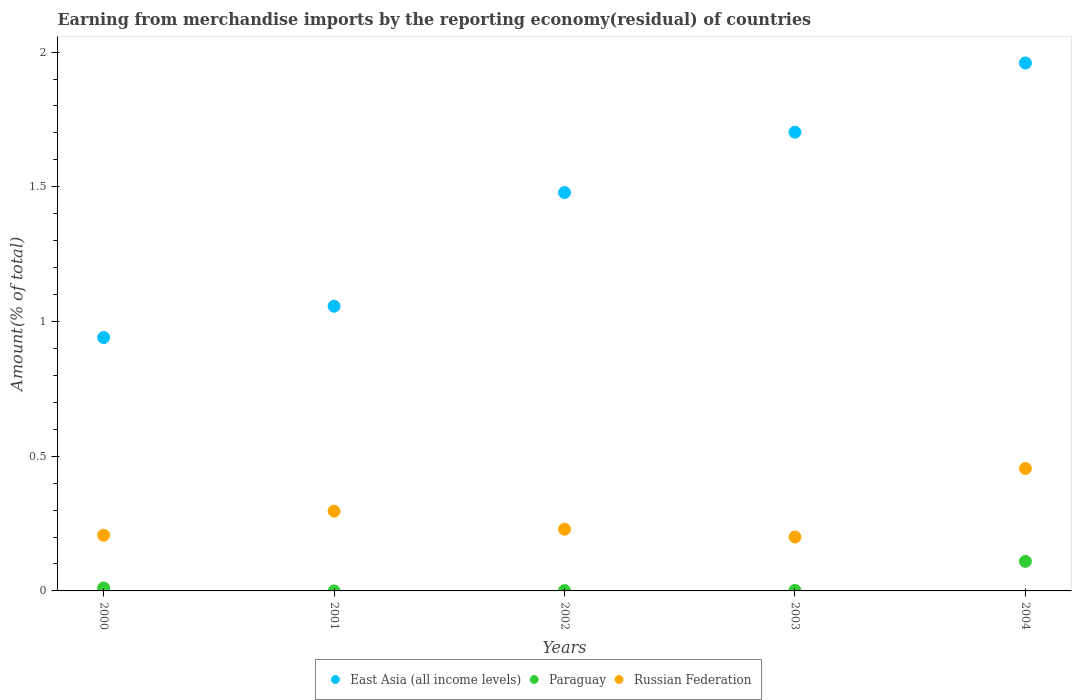Is the number of dotlines equal to the number of legend labels?
Provide a succinct answer. No. What is the percentage of amount earned from merchandise imports in Russian Federation in 2003?
Keep it short and to the point. 0.2. Across all years, what is the maximum percentage of amount earned from merchandise imports in Russian Federation?
Make the answer very short. 0.45. Across all years, what is the minimum percentage of amount earned from merchandise imports in Russian Federation?
Offer a terse response. 0.2. What is the total percentage of amount earned from merchandise imports in Russian Federation in the graph?
Ensure brevity in your answer.  1.39. What is the difference between the percentage of amount earned from merchandise imports in Russian Federation in 2001 and that in 2003?
Your response must be concise. 0.1. What is the difference between the percentage of amount earned from merchandise imports in Russian Federation in 2003 and the percentage of amount earned from merchandise imports in Paraguay in 2001?
Your answer should be very brief. 0.2. What is the average percentage of amount earned from merchandise imports in Paraguay per year?
Offer a very short reply. 0.02. In the year 2002, what is the difference between the percentage of amount earned from merchandise imports in Paraguay and percentage of amount earned from merchandise imports in Russian Federation?
Make the answer very short. -0.23. What is the ratio of the percentage of amount earned from merchandise imports in East Asia (all income levels) in 2001 to that in 2002?
Provide a short and direct response. 0.71. Is the percentage of amount earned from merchandise imports in East Asia (all income levels) in 2002 less than that in 2004?
Your answer should be very brief. Yes. What is the difference between the highest and the second highest percentage of amount earned from merchandise imports in Paraguay?
Provide a succinct answer. 0.1. What is the difference between the highest and the lowest percentage of amount earned from merchandise imports in Russian Federation?
Keep it short and to the point. 0.25. Is the sum of the percentage of amount earned from merchandise imports in East Asia (all income levels) in 2003 and 2004 greater than the maximum percentage of amount earned from merchandise imports in Russian Federation across all years?
Offer a terse response. Yes. Does the percentage of amount earned from merchandise imports in Russian Federation monotonically increase over the years?
Provide a short and direct response. No. Is the percentage of amount earned from merchandise imports in Paraguay strictly greater than the percentage of amount earned from merchandise imports in Russian Federation over the years?
Give a very brief answer. No. Is the percentage of amount earned from merchandise imports in Russian Federation strictly less than the percentage of amount earned from merchandise imports in East Asia (all income levels) over the years?
Your answer should be very brief. Yes. How many years are there in the graph?
Ensure brevity in your answer.  5. What is the difference between two consecutive major ticks on the Y-axis?
Keep it short and to the point. 0.5. Does the graph contain grids?
Provide a succinct answer. No. Where does the legend appear in the graph?
Ensure brevity in your answer.  Bottom center. How many legend labels are there?
Offer a terse response. 3. What is the title of the graph?
Keep it short and to the point. Earning from merchandise imports by the reporting economy(residual) of countries. Does "China" appear as one of the legend labels in the graph?
Provide a succinct answer. No. What is the label or title of the X-axis?
Make the answer very short. Years. What is the label or title of the Y-axis?
Your answer should be very brief. Amount(% of total). What is the Amount(% of total) of East Asia (all income levels) in 2000?
Make the answer very short. 0.94. What is the Amount(% of total) in Paraguay in 2000?
Your response must be concise. 0.01. What is the Amount(% of total) of Russian Federation in 2000?
Keep it short and to the point. 0.21. What is the Amount(% of total) in East Asia (all income levels) in 2001?
Give a very brief answer. 1.06. What is the Amount(% of total) in Paraguay in 2001?
Your response must be concise. 0. What is the Amount(% of total) in Russian Federation in 2001?
Offer a terse response. 0.3. What is the Amount(% of total) in East Asia (all income levels) in 2002?
Make the answer very short. 1.48. What is the Amount(% of total) of Paraguay in 2002?
Offer a very short reply. 0. What is the Amount(% of total) in Russian Federation in 2002?
Keep it short and to the point. 0.23. What is the Amount(% of total) of East Asia (all income levels) in 2003?
Keep it short and to the point. 1.7. What is the Amount(% of total) in Paraguay in 2003?
Provide a succinct answer. 0. What is the Amount(% of total) of Russian Federation in 2003?
Offer a very short reply. 0.2. What is the Amount(% of total) in East Asia (all income levels) in 2004?
Offer a terse response. 1.96. What is the Amount(% of total) of Paraguay in 2004?
Your answer should be compact. 0.11. What is the Amount(% of total) in Russian Federation in 2004?
Give a very brief answer. 0.45. Across all years, what is the maximum Amount(% of total) in East Asia (all income levels)?
Your answer should be very brief. 1.96. Across all years, what is the maximum Amount(% of total) of Paraguay?
Ensure brevity in your answer.  0.11. Across all years, what is the maximum Amount(% of total) of Russian Federation?
Offer a terse response. 0.45. Across all years, what is the minimum Amount(% of total) in East Asia (all income levels)?
Give a very brief answer. 0.94. Across all years, what is the minimum Amount(% of total) in Russian Federation?
Your answer should be compact. 0.2. What is the total Amount(% of total) of East Asia (all income levels) in the graph?
Keep it short and to the point. 7.14. What is the total Amount(% of total) in Paraguay in the graph?
Your answer should be very brief. 0.12. What is the total Amount(% of total) of Russian Federation in the graph?
Give a very brief answer. 1.39. What is the difference between the Amount(% of total) in East Asia (all income levels) in 2000 and that in 2001?
Offer a terse response. -0.12. What is the difference between the Amount(% of total) of Russian Federation in 2000 and that in 2001?
Keep it short and to the point. -0.09. What is the difference between the Amount(% of total) in East Asia (all income levels) in 2000 and that in 2002?
Provide a succinct answer. -0.54. What is the difference between the Amount(% of total) in Paraguay in 2000 and that in 2002?
Provide a succinct answer. 0.01. What is the difference between the Amount(% of total) of Russian Federation in 2000 and that in 2002?
Make the answer very short. -0.02. What is the difference between the Amount(% of total) of East Asia (all income levels) in 2000 and that in 2003?
Make the answer very short. -0.76. What is the difference between the Amount(% of total) in Paraguay in 2000 and that in 2003?
Offer a very short reply. 0.01. What is the difference between the Amount(% of total) in Russian Federation in 2000 and that in 2003?
Offer a terse response. 0.01. What is the difference between the Amount(% of total) in East Asia (all income levels) in 2000 and that in 2004?
Ensure brevity in your answer.  -1.02. What is the difference between the Amount(% of total) in Paraguay in 2000 and that in 2004?
Offer a terse response. -0.1. What is the difference between the Amount(% of total) in Russian Federation in 2000 and that in 2004?
Keep it short and to the point. -0.25. What is the difference between the Amount(% of total) in East Asia (all income levels) in 2001 and that in 2002?
Make the answer very short. -0.42. What is the difference between the Amount(% of total) of Russian Federation in 2001 and that in 2002?
Your answer should be very brief. 0.07. What is the difference between the Amount(% of total) in East Asia (all income levels) in 2001 and that in 2003?
Your answer should be compact. -0.65. What is the difference between the Amount(% of total) in Russian Federation in 2001 and that in 2003?
Give a very brief answer. 0.1. What is the difference between the Amount(% of total) in East Asia (all income levels) in 2001 and that in 2004?
Provide a short and direct response. -0.9. What is the difference between the Amount(% of total) of Russian Federation in 2001 and that in 2004?
Provide a short and direct response. -0.16. What is the difference between the Amount(% of total) of East Asia (all income levels) in 2002 and that in 2003?
Make the answer very short. -0.22. What is the difference between the Amount(% of total) in Paraguay in 2002 and that in 2003?
Keep it short and to the point. -0. What is the difference between the Amount(% of total) in Russian Federation in 2002 and that in 2003?
Offer a terse response. 0.03. What is the difference between the Amount(% of total) of East Asia (all income levels) in 2002 and that in 2004?
Make the answer very short. -0.48. What is the difference between the Amount(% of total) in Paraguay in 2002 and that in 2004?
Make the answer very short. -0.11. What is the difference between the Amount(% of total) of Russian Federation in 2002 and that in 2004?
Your response must be concise. -0.23. What is the difference between the Amount(% of total) of East Asia (all income levels) in 2003 and that in 2004?
Your answer should be very brief. -0.26. What is the difference between the Amount(% of total) in Paraguay in 2003 and that in 2004?
Offer a terse response. -0.11. What is the difference between the Amount(% of total) of Russian Federation in 2003 and that in 2004?
Your response must be concise. -0.25. What is the difference between the Amount(% of total) of East Asia (all income levels) in 2000 and the Amount(% of total) of Russian Federation in 2001?
Ensure brevity in your answer.  0.64. What is the difference between the Amount(% of total) of Paraguay in 2000 and the Amount(% of total) of Russian Federation in 2001?
Give a very brief answer. -0.29. What is the difference between the Amount(% of total) of East Asia (all income levels) in 2000 and the Amount(% of total) of Paraguay in 2002?
Your answer should be compact. 0.94. What is the difference between the Amount(% of total) of East Asia (all income levels) in 2000 and the Amount(% of total) of Russian Federation in 2002?
Provide a succinct answer. 0.71. What is the difference between the Amount(% of total) in Paraguay in 2000 and the Amount(% of total) in Russian Federation in 2002?
Make the answer very short. -0.22. What is the difference between the Amount(% of total) of East Asia (all income levels) in 2000 and the Amount(% of total) of Paraguay in 2003?
Offer a very short reply. 0.94. What is the difference between the Amount(% of total) of East Asia (all income levels) in 2000 and the Amount(% of total) of Russian Federation in 2003?
Provide a short and direct response. 0.74. What is the difference between the Amount(% of total) in Paraguay in 2000 and the Amount(% of total) in Russian Federation in 2003?
Your response must be concise. -0.19. What is the difference between the Amount(% of total) of East Asia (all income levels) in 2000 and the Amount(% of total) of Paraguay in 2004?
Ensure brevity in your answer.  0.83. What is the difference between the Amount(% of total) of East Asia (all income levels) in 2000 and the Amount(% of total) of Russian Federation in 2004?
Give a very brief answer. 0.49. What is the difference between the Amount(% of total) of Paraguay in 2000 and the Amount(% of total) of Russian Federation in 2004?
Ensure brevity in your answer.  -0.44. What is the difference between the Amount(% of total) of East Asia (all income levels) in 2001 and the Amount(% of total) of Paraguay in 2002?
Give a very brief answer. 1.06. What is the difference between the Amount(% of total) in East Asia (all income levels) in 2001 and the Amount(% of total) in Russian Federation in 2002?
Make the answer very short. 0.83. What is the difference between the Amount(% of total) in East Asia (all income levels) in 2001 and the Amount(% of total) in Paraguay in 2003?
Your answer should be very brief. 1.05. What is the difference between the Amount(% of total) in East Asia (all income levels) in 2001 and the Amount(% of total) in Russian Federation in 2003?
Give a very brief answer. 0.86. What is the difference between the Amount(% of total) of East Asia (all income levels) in 2001 and the Amount(% of total) of Paraguay in 2004?
Offer a very short reply. 0.95. What is the difference between the Amount(% of total) in East Asia (all income levels) in 2001 and the Amount(% of total) in Russian Federation in 2004?
Offer a terse response. 0.6. What is the difference between the Amount(% of total) of East Asia (all income levels) in 2002 and the Amount(% of total) of Paraguay in 2003?
Your response must be concise. 1.48. What is the difference between the Amount(% of total) in East Asia (all income levels) in 2002 and the Amount(% of total) in Russian Federation in 2003?
Provide a succinct answer. 1.28. What is the difference between the Amount(% of total) in Paraguay in 2002 and the Amount(% of total) in Russian Federation in 2003?
Your answer should be compact. -0.2. What is the difference between the Amount(% of total) in East Asia (all income levels) in 2002 and the Amount(% of total) in Paraguay in 2004?
Your response must be concise. 1.37. What is the difference between the Amount(% of total) of East Asia (all income levels) in 2002 and the Amount(% of total) of Russian Federation in 2004?
Your response must be concise. 1.02. What is the difference between the Amount(% of total) of Paraguay in 2002 and the Amount(% of total) of Russian Federation in 2004?
Give a very brief answer. -0.45. What is the difference between the Amount(% of total) in East Asia (all income levels) in 2003 and the Amount(% of total) in Paraguay in 2004?
Offer a terse response. 1.59. What is the difference between the Amount(% of total) in East Asia (all income levels) in 2003 and the Amount(% of total) in Russian Federation in 2004?
Your response must be concise. 1.25. What is the difference between the Amount(% of total) in Paraguay in 2003 and the Amount(% of total) in Russian Federation in 2004?
Keep it short and to the point. -0.45. What is the average Amount(% of total) in East Asia (all income levels) per year?
Your response must be concise. 1.43. What is the average Amount(% of total) of Paraguay per year?
Provide a succinct answer. 0.02. What is the average Amount(% of total) of Russian Federation per year?
Give a very brief answer. 0.28. In the year 2000, what is the difference between the Amount(% of total) of East Asia (all income levels) and Amount(% of total) of Paraguay?
Provide a short and direct response. 0.93. In the year 2000, what is the difference between the Amount(% of total) in East Asia (all income levels) and Amount(% of total) in Russian Federation?
Offer a very short reply. 0.73. In the year 2000, what is the difference between the Amount(% of total) of Paraguay and Amount(% of total) of Russian Federation?
Make the answer very short. -0.2. In the year 2001, what is the difference between the Amount(% of total) of East Asia (all income levels) and Amount(% of total) of Russian Federation?
Ensure brevity in your answer.  0.76. In the year 2002, what is the difference between the Amount(% of total) in East Asia (all income levels) and Amount(% of total) in Paraguay?
Your answer should be very brief. 1.48. In the year 2002, what is the difference between the Amount(% of total) in East Asia (all income levels) and Amount(% of total) in Russian Federation?
Your response must be concise. 1.25. In the year 2002, what is the difference between the Amount(% of total) of Paraguay and Amount(% of total) of Russian Federation?
Make the answer very short. -0.23. In the year 2003, what is the difference between the Amount(% of total) of East Asia (all income levels) and Amount(% of total) of Paraguay?
Give a very brief answer. 1.7. In the year 2003, what is the difference between the Amount(% of total) of East Asia (all income levels) and Amount(% of total) of Russian Federation?
Your answer should be very brief. 1.5. In the year 2003, what is the difference between the Amount(% of total) of Paraguay and Amount(% of total) of Russian Federation?
Provide a succinct answer. -0.2. In the year 2004, what is the difference between the Amount(% of total) in East Asia (all income levels) and Amount(% of total) in Paraguay?
Make the answer very short. 1.85. In the year 2004, what is the difference between the Amount(% of total) of East Asia (all income levels) and Amount(% of total) of Russian Federation?
Make the answer very short. 1.51. In the year 2004, what is the difference between the Amount(% of total) in Paraguay and Amount(% of total) in Russian Federation?
Provide a short and direct response. -0.34. What is the ratio of the Amount(% of total) in East Asia (all income levels) in 2000 to that in 2001?
Offer a very short reply. 0.89. What is the ratio of the Amount(% of total) in Russian Federation in 2000 to that in 2001?
Give a very brief answer. 0.7. What is the ratio of the Amount(% of total) of East Asia (all income levels) in 2000 to that in 2002?
Offer a very short reply. 0.64. What is the ratio of the Amount(% of total) in Paraguay in 2000 to that in 2002?
Ensure brevity in your answer.  8.4. What is the ratio of the Amount(% of total) of Russian Federation in 2000 to that in 2002?
Your response must be concise. 0.9. What is the ratio of the Amount(% of total) of East Asia (all income levels) in 2000 to that in 2003?
Provide a succinct answer. 0.55. What is the ratio of the Amount(% of total) of Paraguay in 2000 to that in 2003?
Keep it short and to the point. 5.86. What is the ratio of the Amount(% of total) in Russian Federation in 2000 to that in 2003?
Keep it short and to the point. 1.03. What is the ratio of the Amount(% of total) of East Asia (all income levels) in 2000 to that in 2004?
Ensure brevity in your answer.  0.48. What is the ratio of the Amount(% of total) in Paraguay in 2000 to that in 2004?
Give a very brief answer. 0.1. What is the ratio of the Amount(% of total) in Russian Federation in 2000 to that in 2004?
Your response must be concise. 0.45. What is the ratio of the Amount(% of total) in East Asia (all income levels) in 2001 to that in 2002?
Provide a short and direct response. 0.71. What is the ratio of the Amount(% of total) of Russian Federation in 2001 to that in 2002?
Offer a very short reply. 1.29. What is the ratio of the Amount(% of total) of East Asia (all income levels) in 2001 to that in 2003?
Offer a very short reply. 0.62. What is the ratio of the Amount(% of total) in Russian Federation in 2001 to that in 2003?
Provide a succinct answer. 1.48. What is the ratio of the Amount(% of total) in East Asia (all income levels) in 2001 to that in 2004?
Offer a terse response. 0.54. What is the ratio of the Amount(% of total) in Russian Federation in 2001 to that in 2004?
Your answer should be very brief. 0.65. What is the ratio of the Amount(% of total) in East Asia (all income levels) in 2002 to that in 2003?
Ensure brevity in your answer.  0.87. What is the ratio of the Amount(% of total) of Paraguay in 2002 to that in 2003?
Ensure brevity in your answer.  0.7. What is the ratio of the Amount(% of total) of Russian Federation in 2002 to that in 2003?
Keep it short and to the point. 1.14. What is the ratio of the Amount(% of total) of East Asia (all income levels) in 2002 to that in 2004?
Make the answer very short. 0.75. What is the ratio of the Amount(% of total) of Paraguay in 2002 to that in 2004?
Your response must be concise. 0.01. What is the ratio of the Amount(% of total) in Russian Federation in 2002 to that in 2004?
Your answer should be compact. 0.5. What is the ratio of the Amount(% of total) of East Asia (all income levels) in 2003 to that in 2004?
Offer a terse response. 0.87. What is the ratio of the Amount(% of total) of Paraguay in 2003 to that in 2004?
Ensure brevity in your answer.  0.02. What is the ratio of the Amount(% of total) in Russian Federation in 2003 to that in 2004?
Your answer should be compact. 0.44. What is the difference between the highest and the second highest Amount(% of total) of East Asia (all income levels)?
Ensure brevity in your answer.  0.26. What is the difference between the highest and the second highest Amount(% of total) in Paraguay?
Your answer should be compact. 0.1. What is the difference between the highest and the second highest Amount(% of total) of Russian Federation?
Offer a terse response. 0.16. What is the difference between the highest and the lowest Amount(% of total) in East Asia (all income levels)?
Provide a short and direct response. 1.02. What is the difference between the highest and the lowest Amount(% of total) of Paraguay?
Your answer should be very brief. 0.11. What is the difference between the highest and the lowest Amount(% of total) in Russian Federation?
Keep it short and to the point. 0.25. 